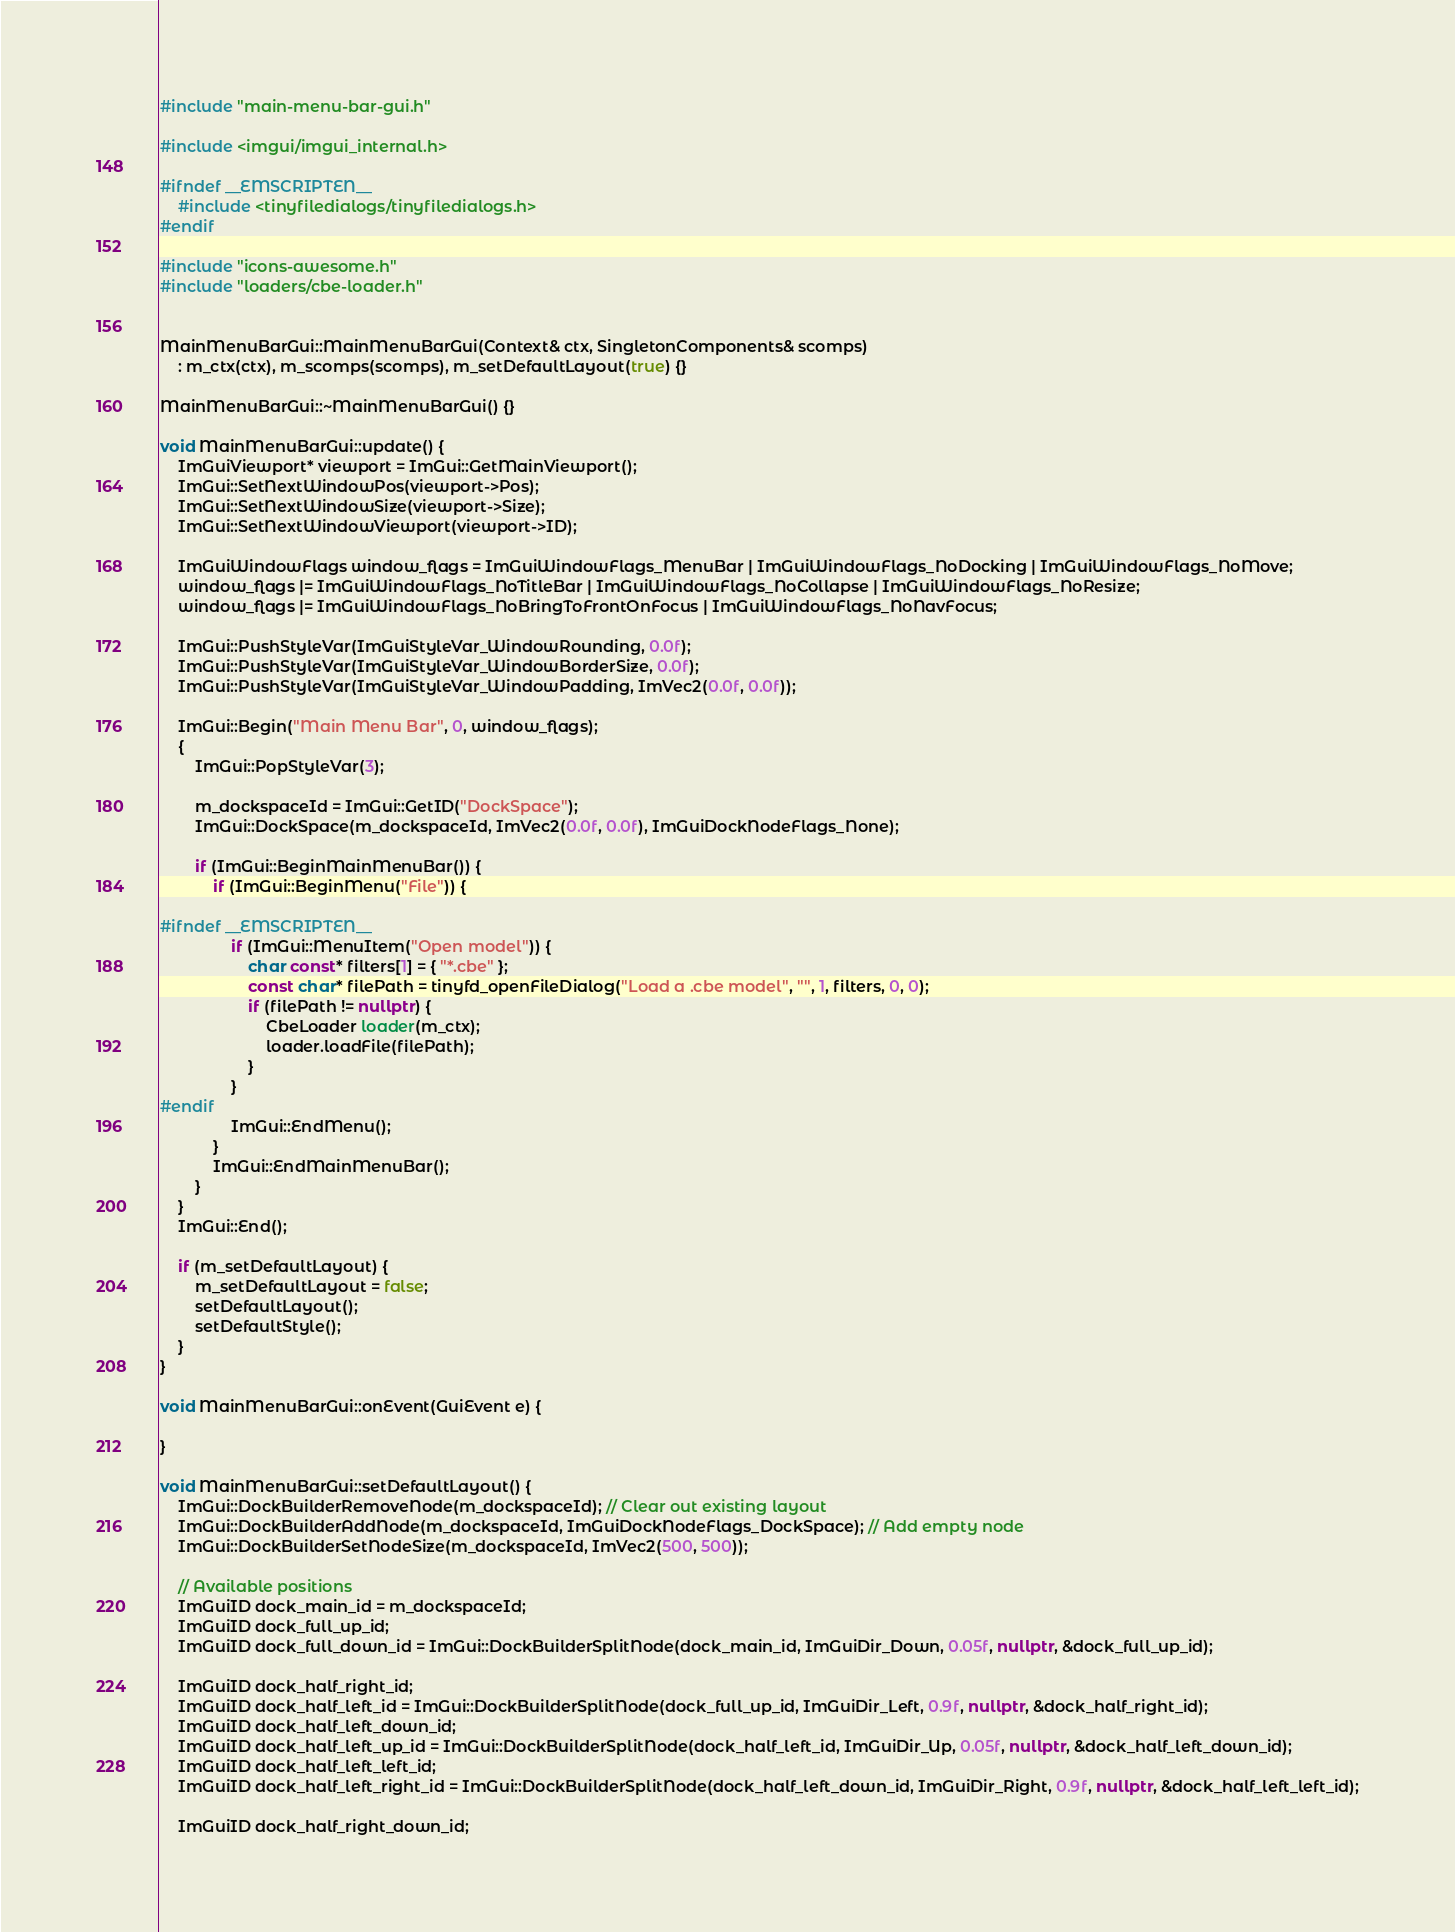<code> <loc_0><loc_0><loc_500><loc_500><_C++_>#include "main-menu-bar-gui.h"

#include <imgui/imgui_internal.h>

#ifndef __EMSCRIPTEN__
    #include <tinyfiledialogs/tinyfiledialogs.h>
#endif

#include "icons-awesome.h"
#include "loaders/cbe-loader.h"


MainMenuBarGui::MainMenuBarGui(Context& ctx, SingletonComponents& scomps) 
    : m_ctx(ctx), m_scomps(scomps), m_setDefaultLayout(true) {}

MainMenuBarGui::~MainMenuBarGui() {}

void MainMenuBarGui::update() {
    ImGuiViewport* viewport = ImGui::GetMainViewport();
    ImGui::SetNextWindowPos(viewport->Pos);
    ImGui::SetNextWindowSize(viewport->Size);
    ImGui::SetNextWindowViewport(viewport->ID);

    ImGuiWindowFlags window_flags = ImGuiWindowFlags_MenuBar | ImGuiWindowFlags_NoDocking | ImGuiWindowFlags_NoMove;
    window_flags |= ImGuiWindowFlags_NoTitleBar | ImGuiWindowFlags_NoCollapse | ImGuiWindowFlags_NoResize;
    window_flags |= ImGuiWindowFlags_NoBringToFrontOnFocus | ImGuiWindowFlags_NoNavFocus;

    ImGui::PushStyleVar(ImGuiStyleVar_WindowRounding, 0.0f);
    ImGui::PushStyleVar(ImGuiStyleVar_WindowBorderSize, 0.0f);
    ImGui::PushStyleVar(ImGuiStyleVar_WindowPadding, ImVec2(0.0f, 0.0f));

    ImGui::Begin("Main Menu Bar", 0, window_flags);
    {
        ImGui::PopStyleVar(3);

        m_dockspaceId = ImGui::GetID("DockSpace");
        ImGui::DockSpace(m_dockspaceId, ImVec2(0.0f, 0.0f), ImGuiDockNodeFlags_None);

        if (ImGui::BeginMainMenuBar()) {
            if (ImGui::BeginMenu("File")) {

#ifndef __EMSCRIPTEN__
                if (ImGui::MenuItem("Open model")) {
                    char const* filters[1] = { "*.cbe" };
                    const char* filePath = tinyfd_openFileDialog("Load a .cbe model", "", 1, filters, 0, 0);
                    if (filePath != nullptr) {
                        CbeLoader loader(m_ctx);
                        loader.loadFile(filePath);
                    }
                }
#endif
                ImGui::EndMenu();
            }
            ImGui::EndMainMenuBar();
        }
    }
    ImGui::End();

    if (m_setDefaultLayout) {
        m_setDefaultLayout = false;
        setDefaultLayout();
        setDefaultStyle();
    }
}

void MainMenuBarGui::onEvent(GuiEvent e) {

}

void MainMenuBarGui::setDefaultLayout() {
    ImGui::DockBuilderRemoveNode(m_dockspaceId); // Clear out existing layout
    ImGui::DockBuilderAddNode(m_dockspaceId, ImGuiDockNodeFlags_DockSpace); // Add empty node
    ImGui::DockBuilderSetNodeSize(m_dockspaceId, ImVec2(500, 500));

    // Available positions
    ImGuiID dock_main_id = m_dockspaceId;
    ImGuiID dock_full_up_id;
	ImGuiID dock_full_down_id = ImGui::DockBuilderSplitNode(dock_main_id, ImGuiDir_Down, 0.05f, nullptr, &dock_full_up_id);
    
    ImGuiID dock_half_right_id;
    ImGuiID dock_half_left_id = ImGui::DockBuilderSplitNode(dock_full_up_id, ImGuiDir_Left, 0.9f, nullptr, &dock_half_right_id);
    ImGuiID dock_half_left_down_id;
    ImGuiID dock_half_left_up_id = ImGui::DockBuilderSplitNode(dock_half_left_id, ImGuiDir_Up, 0.05f, nullptr, &dock_half_left_down_id);
    ImGuiID dock_half_left_left_id;
    ImGuiID dock_half_left_right_id = ImGui::DockBuilderSplitNode(dock_half_left_down_id, ImGuiDir_Right, 0.9f, nullptr, &dock_half_left_left_id);

    ImGuiID dock_half_right_down_id;</code> 